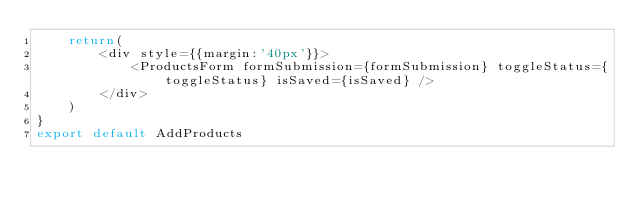Convert code to text. <code><loc_0><loc_0><loc_500><loc_500><_JavaScript_>    return(
        <div style={{margin:'40px'}}>
            <ProductsForm formSubmission={formSubmission} toggleStatus={toggleStatus} isSaved={isSaved} />
        </div>
    )
}
export default AddProducts</code> 